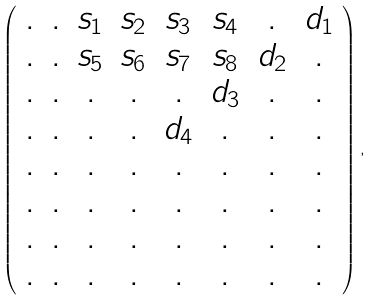Convert formula to latex. <formula><loc_0><loc_0><loc_500><loc_500>\left ( \begin{array} { c c c c c c c c } . & . & s _ { 1 } & s _ { 2 } & s _ { 3 } & s _ { 4 } & . & d _ { 1 } \\ . & . & s _ { 5 } & s _ { 6 } & s _ { 7 } & s _ { 8 } & d _ { 2 } & . \\ . & . & . & . & . & d _ { 3 } & . & . \\ . & . & . & . & d _ { 4 } & . & . & . \\ . & . & . & . & . & . & . & . \\ . & . & . & . & . & . & . & . \\ . & . & . & . & . & . & . & . \\ . & . & . & . & . & . & . & . \end{array} \right ) ,</formula> 